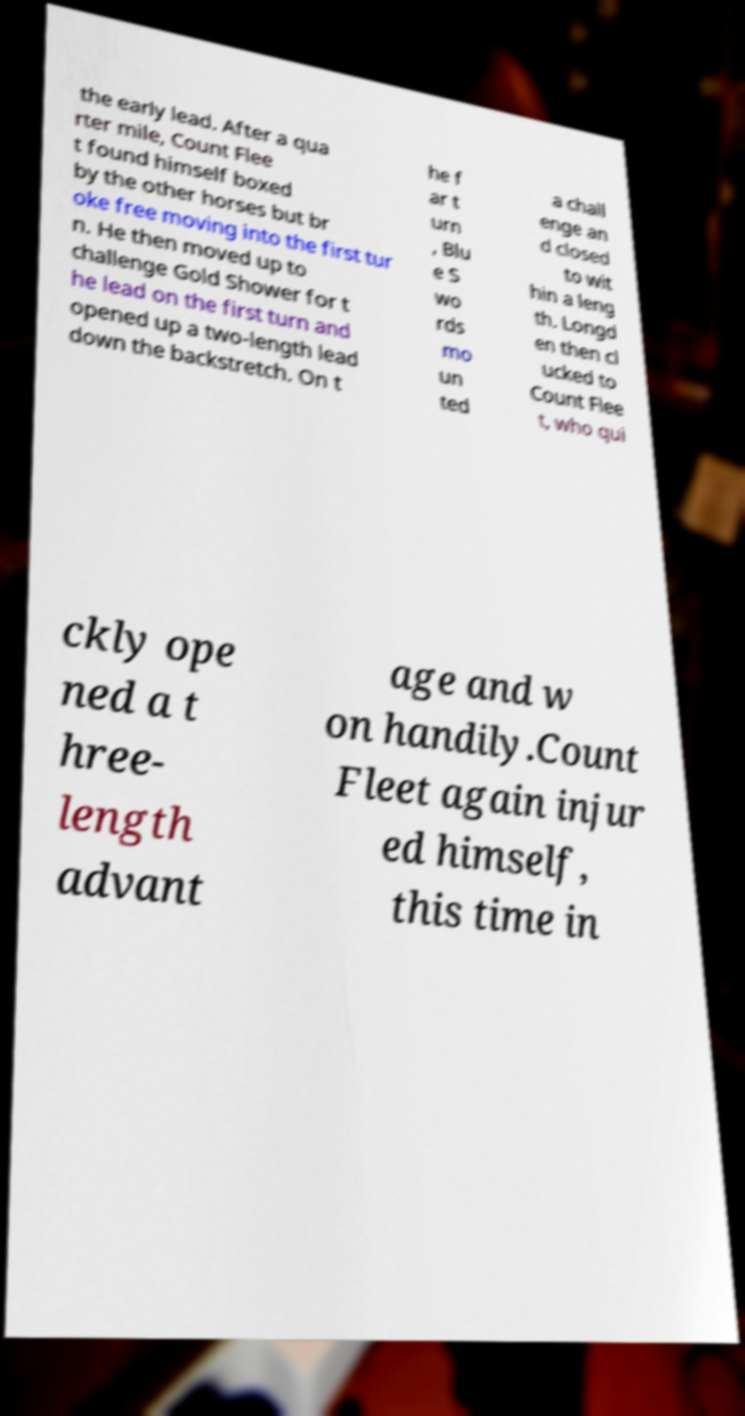For documentation purposes, I need the text within this image transcribed. Could you provide that? the early lead. After a qua rter mile, Count Flee t found himself boxed by the other horses but br oke free moving into the first tur n. He then moved up to challenge Gold Shower for t he lead on the first turn and opened up a two-length lead down the backstretch. On t he f ar t urn , Blu e S wo rds mo un ted a chall enge an d closed to wit hin a leng th. Longd en then cl ucked to Count Flee t, who qui ckly ope ned a t hree- length advant age and w on handily.Count Fleet again injur ed himself, this time in 